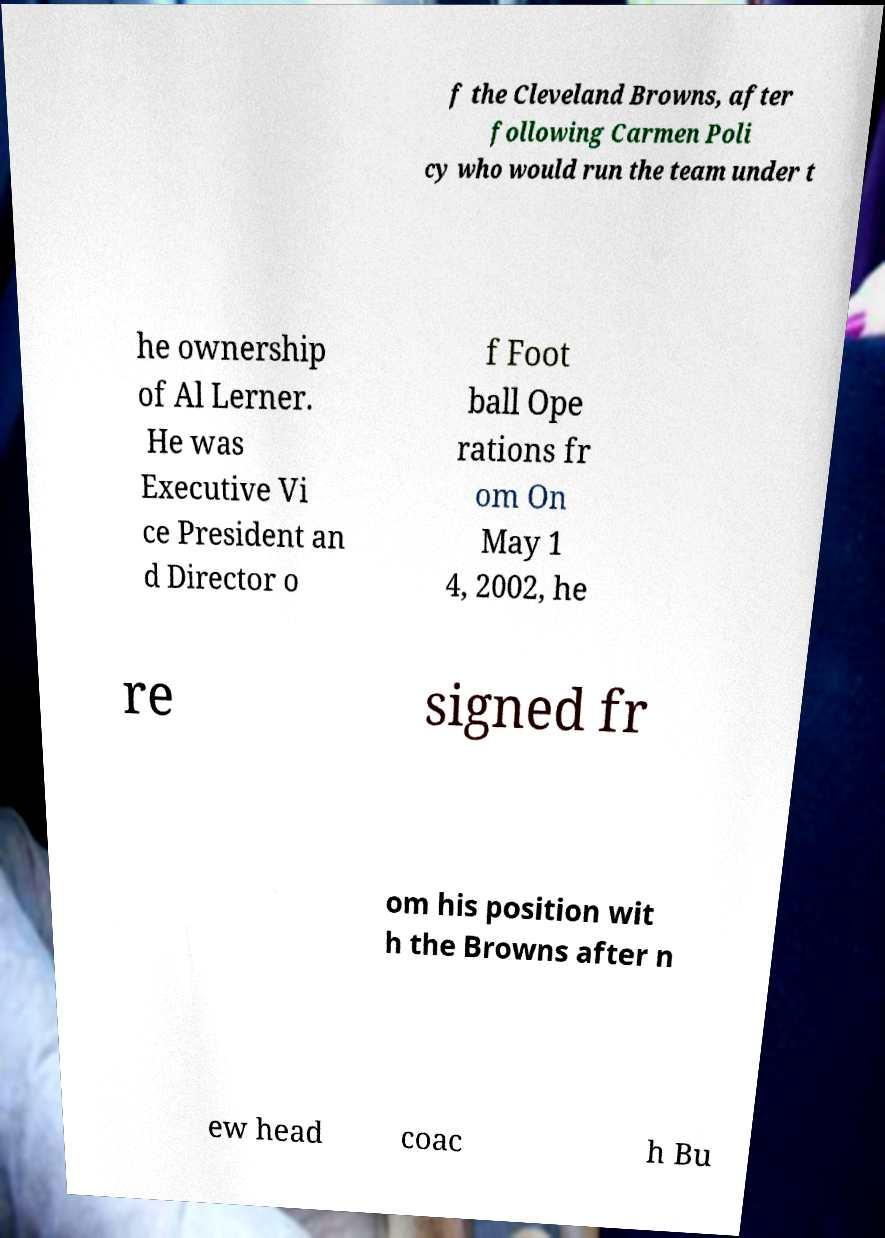Could you assist in decoding the text presented in this image and type it out clearly? f the Cleveland Browns, after following Carmen Poli cy who would run the team under t he ownership of Al Lerner. He was Executive Vi ce President an d Director o f Foot ball Ope rations fr om On May 1 4, 2002, he re signed fr om his position wit h the Browns after n ew head coac h Bu 